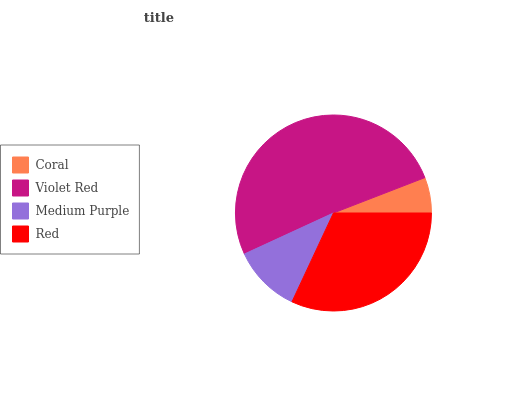Is Coral the minimum?
Answer yes or no. Yes. Is Violet Red the maximum?
Answer yes or no. Yes. Is Medium Purple the minimum?
Answer yes or no. No. Is Medium Purple the maximum?
Answer yes or no. No. Is Violet Red greater than Medium Purple?
Answer yes or no. Yes. Is Medium Purple less than Violet Red?
Answer yes or no. Yes. Is Medium Purple greater than Violet Red?
Answer yes or no. No. Is Violet Red less than Medium Purple?
Answer yes or no. No. Is Red the high median?
Answer yes or no. Yes. Is Medium Purple the low median?
Answer yes or no. Yes. Is Violet Red the high median?
Answer yes or no. No. Is Coral the low median?
Answer yes or no. No. 